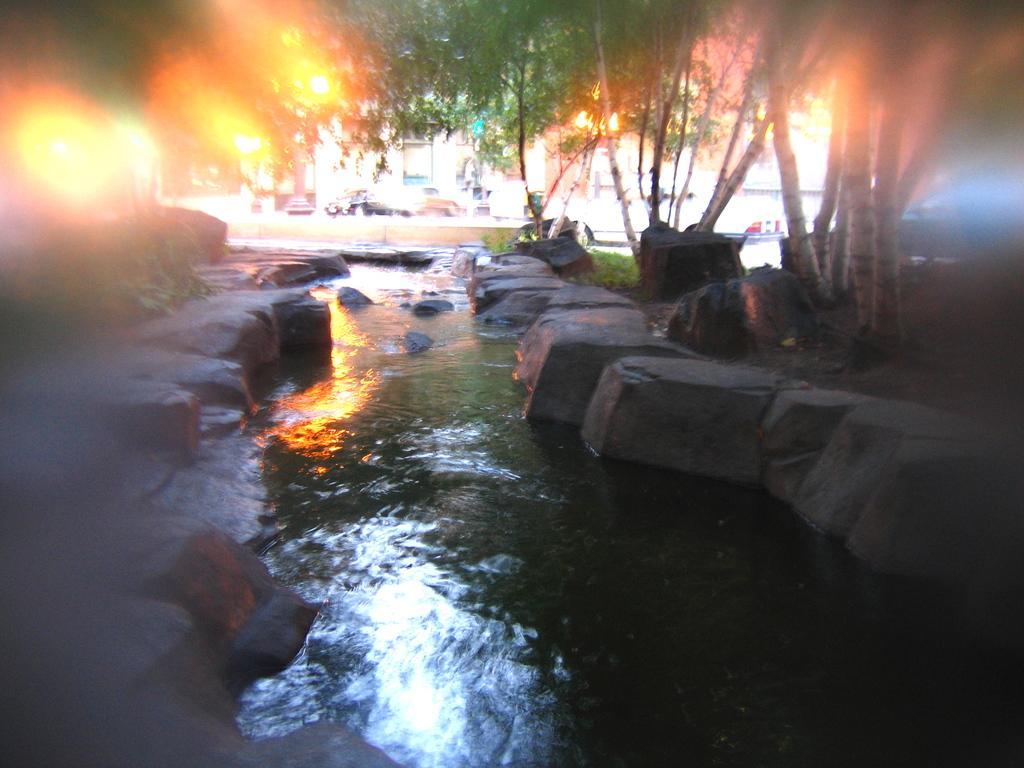How would you summarize this image in a sentence or two? This picture is clicked outside. In the foreground we can see the rocks, water body and the green grass, trees and some other items. In the background we can see the buildings, vehicles and the fire like thing and some objects. 